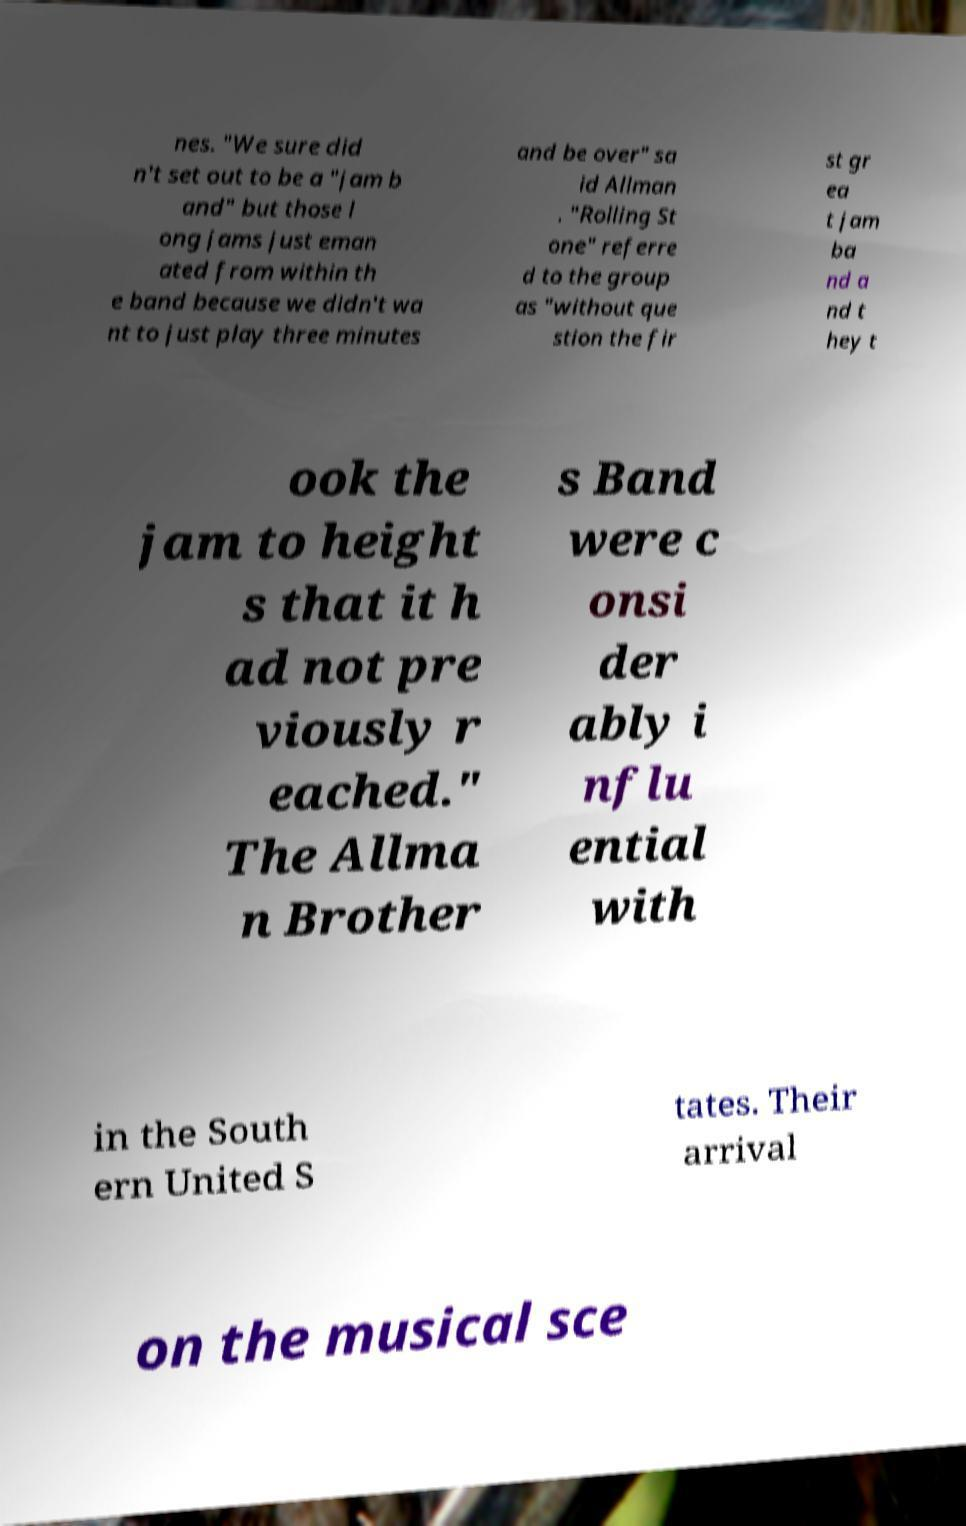There's text embedded in this image that I need extracted. Can you transcribe it verbatim? nes. "We sure did n't set out to be a "jam b and" but those l ong jams just eman ated from within th e band because we didn't wa nt to just play three minutes and be over" sa id Allman . "Rolling St one" referre d to the group as "without que stion the fir st gr ea t jam ba nd a nd t hey t ook the jam to height s that it h ad not pre viously r eached." The Allma n Brother s Band were c onsi der ably i nflu ential with in the South ern United S tates. Their arrival on the musical sce 